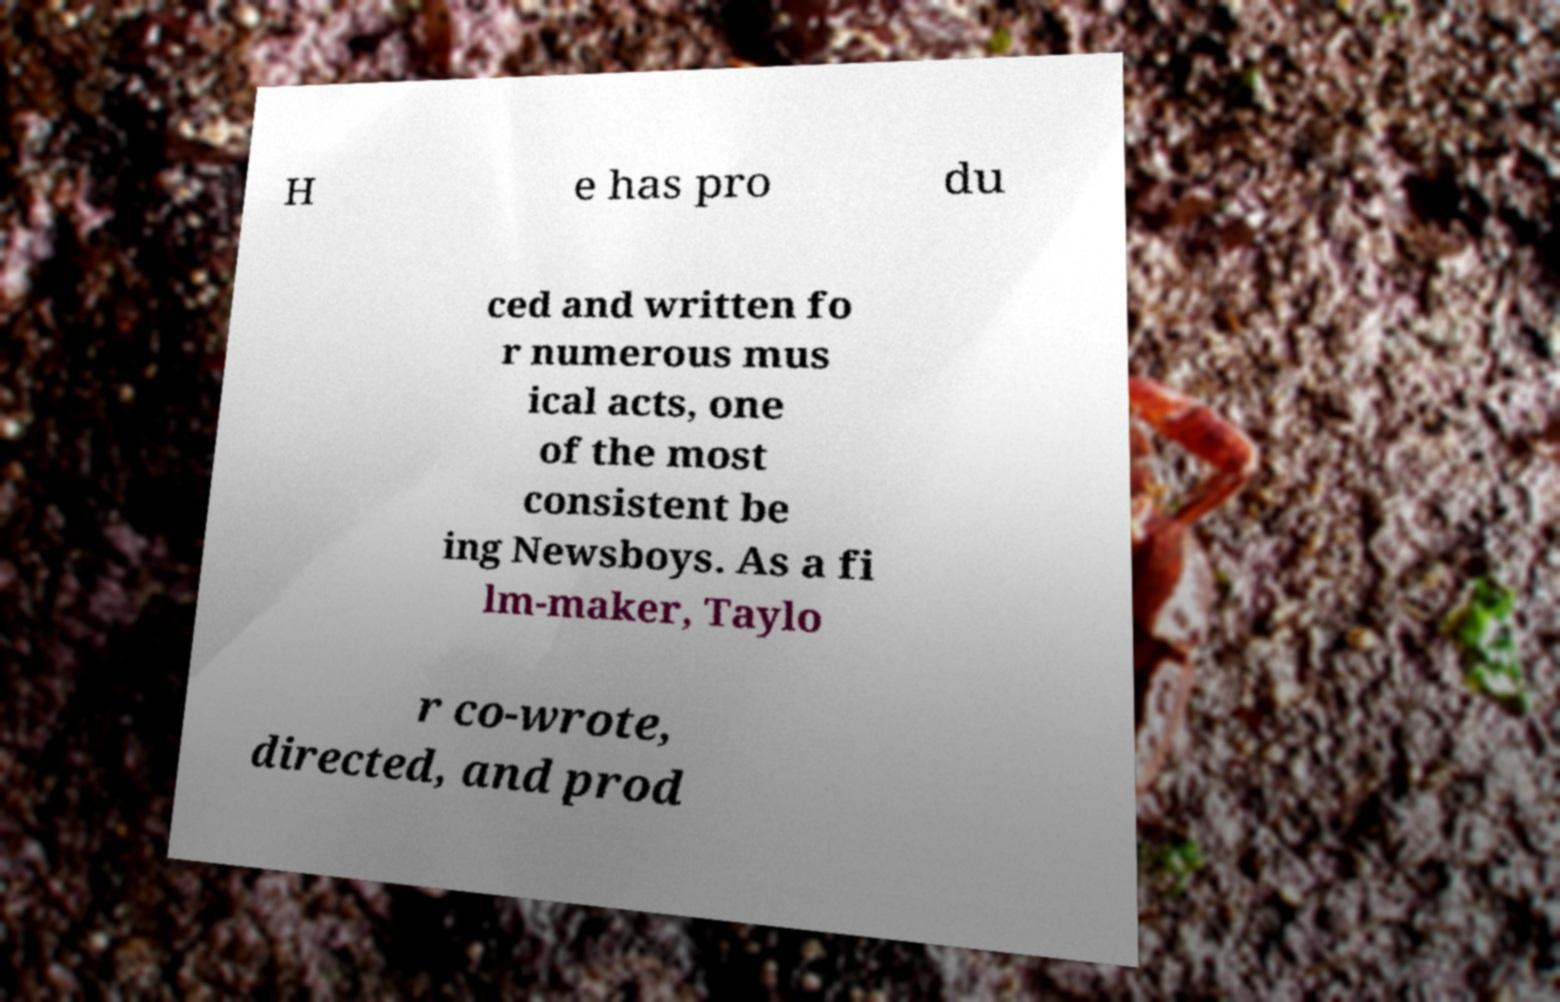Could you assist in decoding the text presented in this image and type it out clearly? H e has pro du ced and written fo r numerous mus ical acts, one of the most consistent be ing Newsboys. As a fi lm-maker, Taylo r co-wrote, directed, and prod 